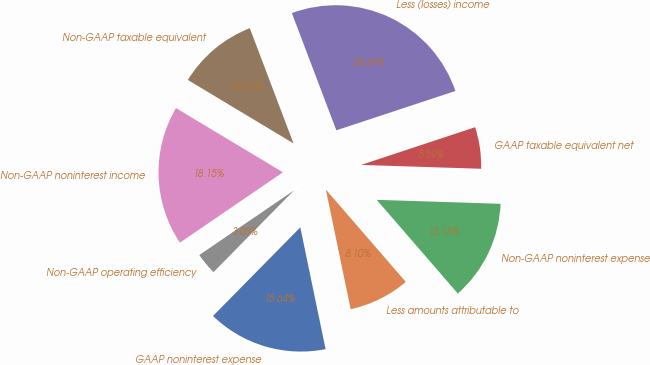Convert chart to OTSL. <chart><loc_0><loc_0><loc_500><loc_500><pie_chart><fcel>GAAP noninterest expense<fcel>Less amounts attributable to<fcel>Non-GAAP noninterest expense<fcel>GAAP taxable equivalent net<fcel>Less (losses) income<fcel>Non-GAAP taxable equivalent<fcel>Non-GAAP noninterest income<fcel>Non-GAAP operating efficiency<nl><fcel>15.64%<fcel>8.1%<fcel>13.13%<fcel>5.59%<fcel>25.69%<fcel>10.62%<fcel>18.15%<fcel>3.08%<nl></chart> 